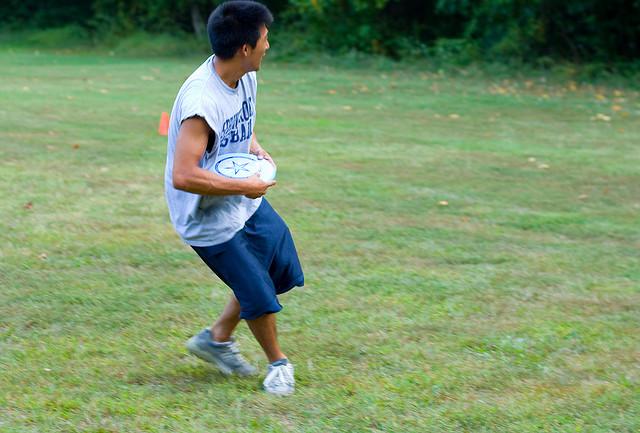What game is he playing?
Keep it brief. Frisbee. How old is the boy with the frisbee?
Short answer required. 18. Is this boy blond??
Answer briefly. No. Does the man have shoes on?
Short answer required. Yes. What is the boy holding in his hand?
Give a very brief answer. Frisbee. Is there a fence?
Answer briefly. No. Is this person playing alone?
Answer briefly. No. What color is this guy wearing?
Give a very brief answer. Blue. 